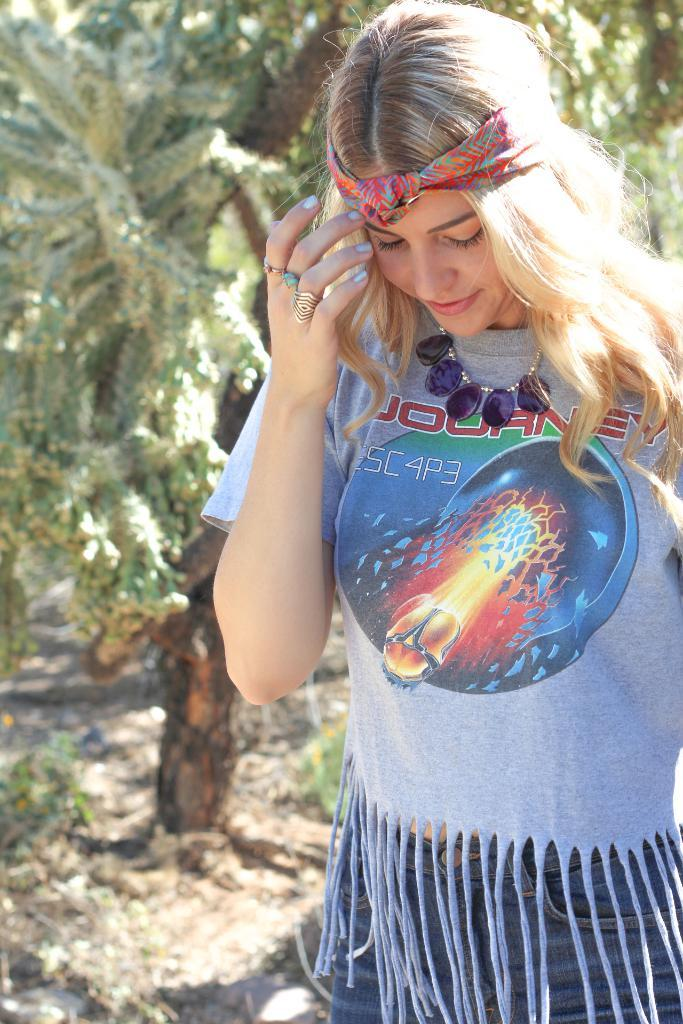What is the main subject of the image? There is a woman standing in the image. What is the woman wearing on her head? The woman has a cloth tightened to her head. What can be seen in the background of the image? There are trees in the background of the image. What type of eggnog is the woman holding in the image? There is no eggnog present in the image; the woman is not holding anything. 